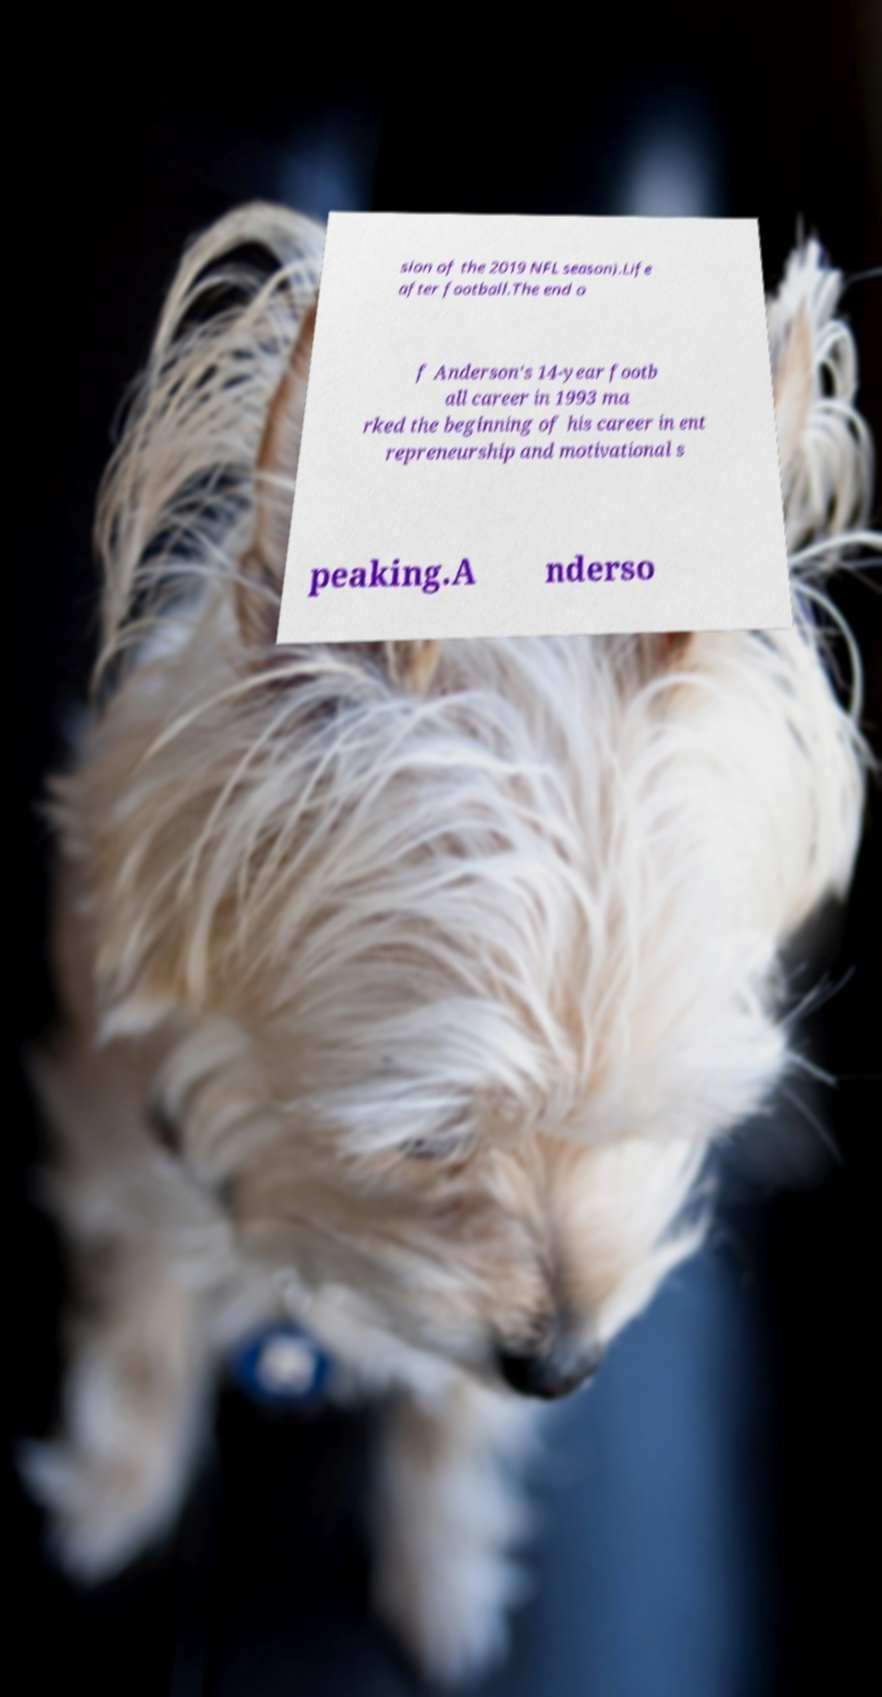For documentation purposes, I need the text within this image transcribed. Could you provide that? sion of the 2019 NFL season).Life after football.The end o f Anderson's 14-year footb all career in 1993 ma rked the beginning of his career in ent repreneurship and motivational s peaking.A nderso 